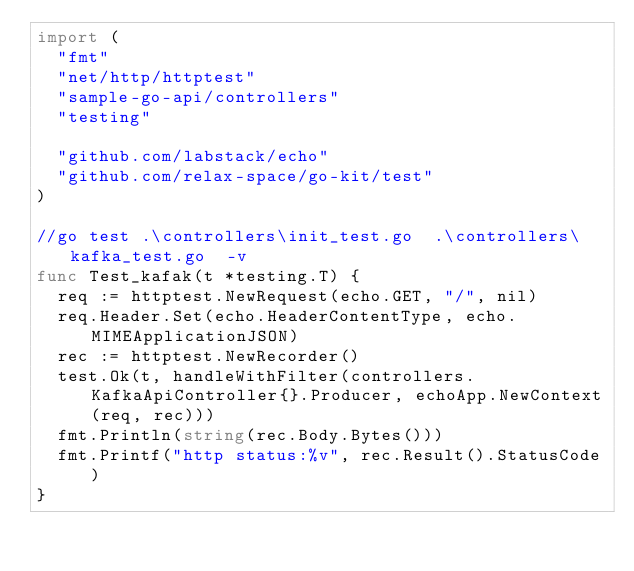<code> <loc_0><loc_0><loc_500><loc_500><_Go_>import (
	"fmt"
	"net/http/httptest"
	"sample-go-api/controllers"
	"testing"

	"github.com/labstack/echo"
	"github.com/relax-space/go-kit/test"
)

//go test .\controllers\init_test.go  .\controllers\kafka_test.go  -v
func Test_kafak(t *testing.T) {
	req := httptest.NewRequest(echo.GET, "/", nil)
	req.Header.Set(echo.HeaderContentType, echo.MIMEApplicationJSON)
	rec := httptest.NewRecorder()
	test.Ok(t, handleWithFilter(controllers.KafkaApiController{}.Producer, echoApp.NewContext(req, rec)))
	fmt.Println(string(rec.Body.Bytes()))
	fmt.Printf("http status:%v", rec.Result().StatusCode)
}
</code> 